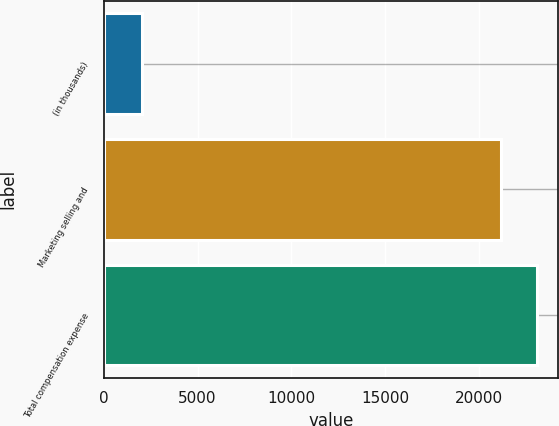Convert chart. <chart><loc_0><loc_0><loc_500><loc_500><bar_chart><fcel>(in thousands)<fcel>Marketing selling and<fcel>Total compensation expense<nl><fcel>2013<fcel>21178<fcel>23094.5<nl></chart> 